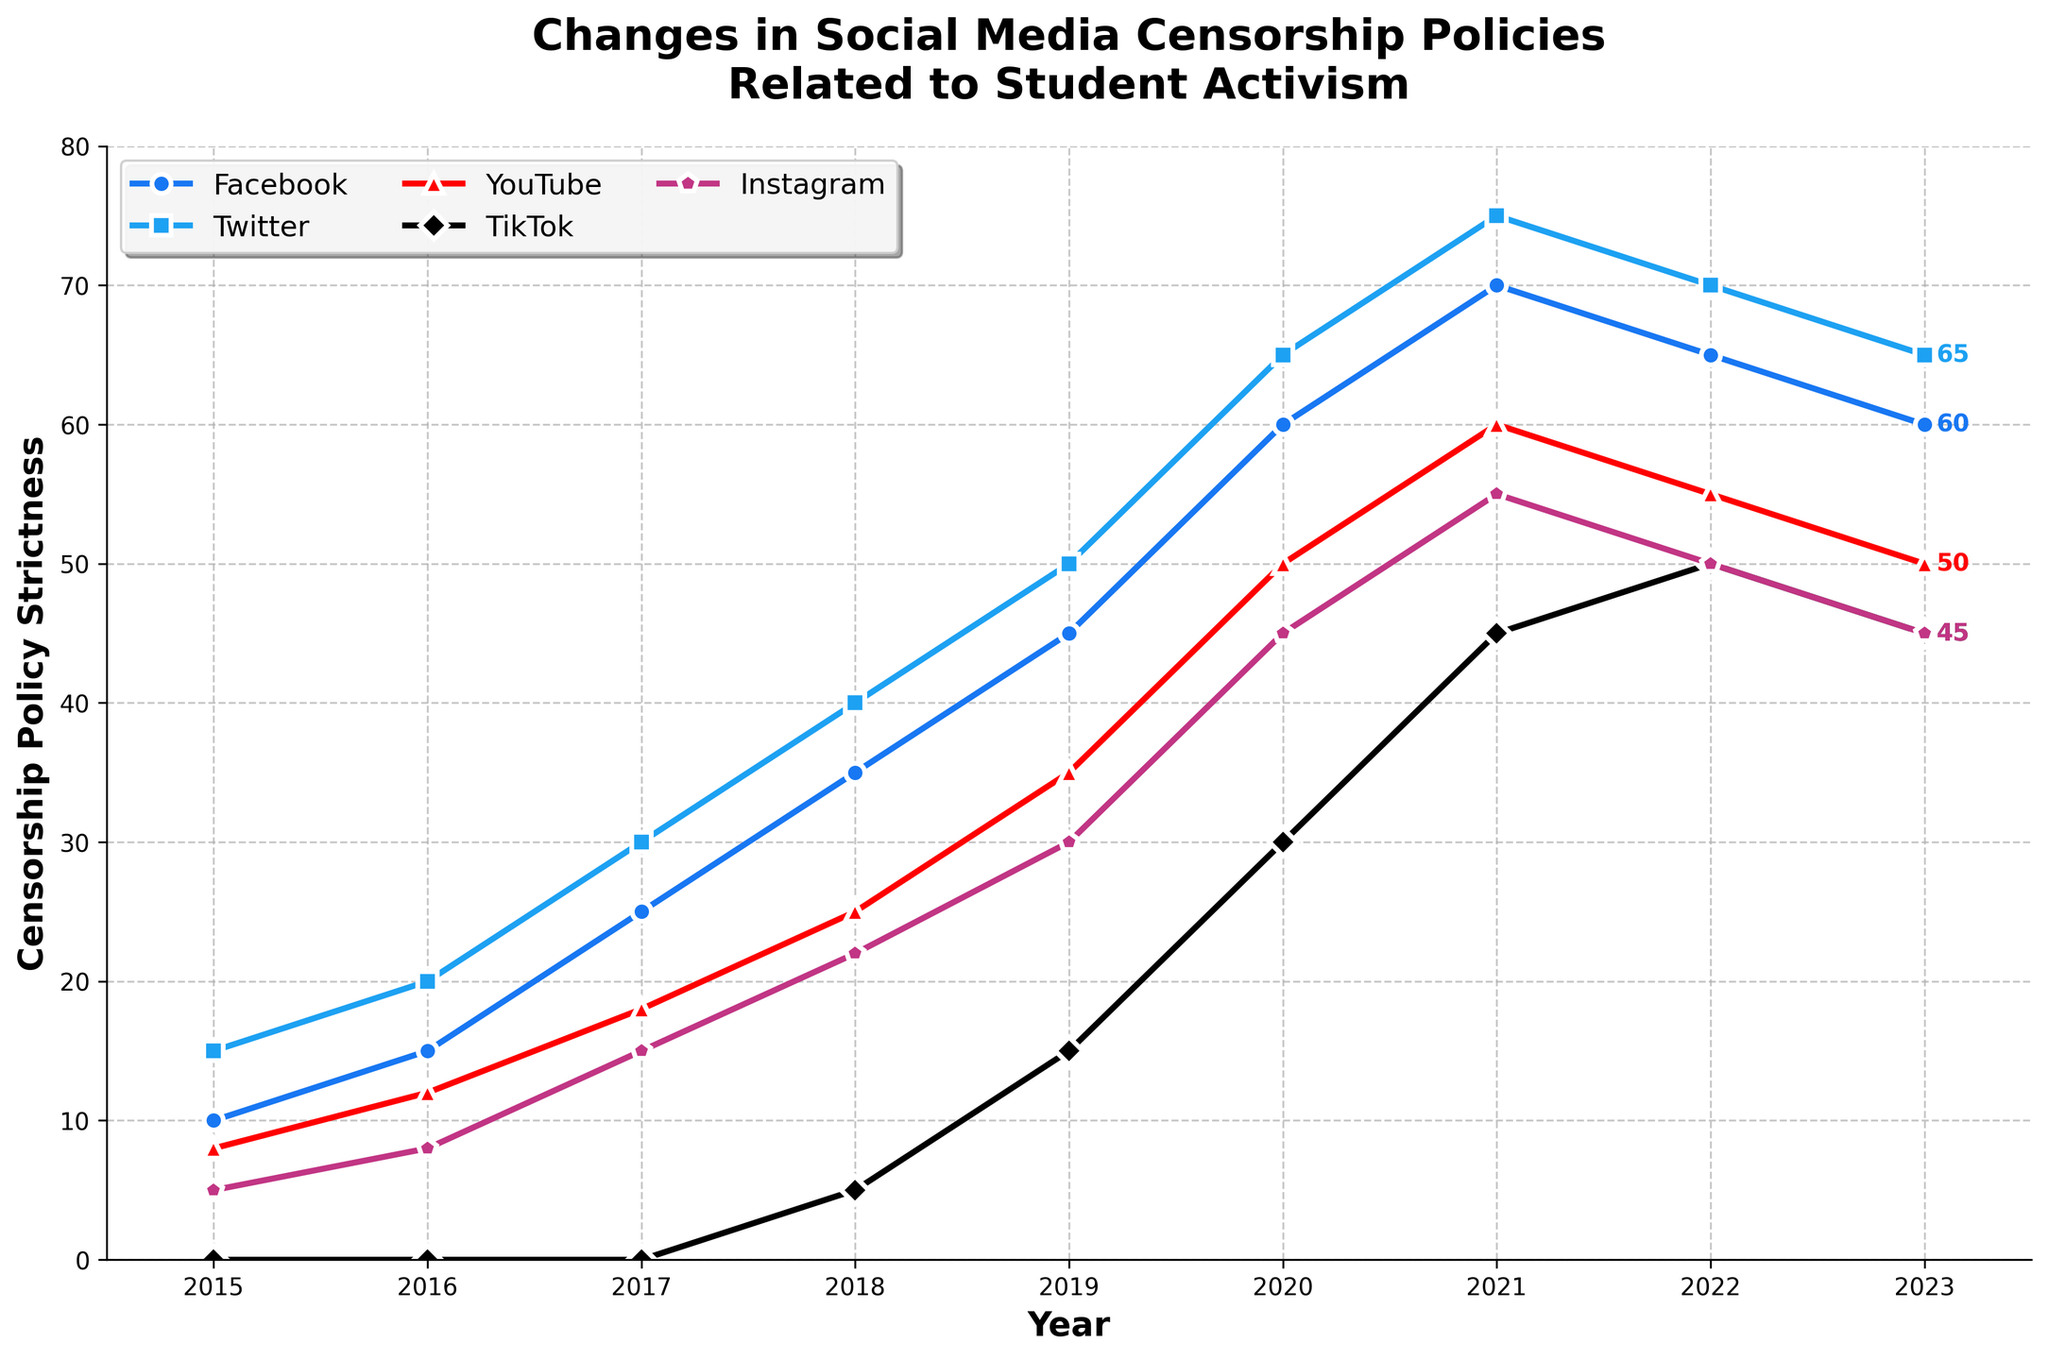What year did Facebook's censorship policy strictness peak? By examining the line for Facebook, you can see that it reaches its highest point in 2021 before declining in subsequent years.
Answer: 2021 Which platform showed the earliest start in censorship policy enforcement related to student activism? By looking at the beginning of each line, Facebook, Twitter, YouTube, and Instagram all started in 2015, but TikTok starts much later, in 2018.
Answer: Facebook, Twitter, YouTube, and Instagram How much stricter did YouTube's censorship policy become from 2015 to 2020? YouTube's strictness level in 2015 is 8, and it increases to 50 in 2020. The difference is 50 - 8.
Answer: 42 In which year did Instagram implement the same level of censorship strictness as TikTok? By comparing the Instagram and TikTok lines, in the year 2022, both platforms show a level of 50.
Answer: 2022 Which platform had the highest increase in strictness from 2019 to 2020? By looking at the lines and checking the vertical difference between 2019 and 2020, Facebook increased by 15 (60 - 45), Twitter by 15 (65 - 50), YouTube by 15 (50 - 35), TikTok by 15 (30 - 15), Instagram by 15 (45 - 30). Since all increases are equal, any platform can be the answer.
Answer: Facebook, Twitter, YouTube, TikTok, Instagram For how many years did Twitter maintain a higher strictness level than Facebook? By following the lines for Twitter and Facebook, Twitter maintains higher values in 2017-2023.
Answer: 7 years What was the average strictness level of Instagram from 2015 to 2023? Adding up the Instagram values (5 + 8 + 15 + 22 + 30 + 45 + 55 + 50 + 45) and dividing by the number of years (9) gives the average. (5 + 8 + 15 + 22 + 30 + 45 + 55 + 50 + 45)/9 = 27.2.
Answer: 27.2 Which platform experienced the first drop in its censorship policy strictness? By checking the lines, YouTube experiences its first drop from 2021 to 2022.
Answer: YouTube How many years did it take for TikTok to start implementing censorship policies after 2015? TikTok started in 2018, which is 3 years after 2015.
Answer: 3 years How much stricter was Twitter's censorship policy in 2020 compared to YouTube's? Twitter’s strictness in 2020 is 65, while YouTube’s is 50; the difference is 65 - 50.
Answer: 15 